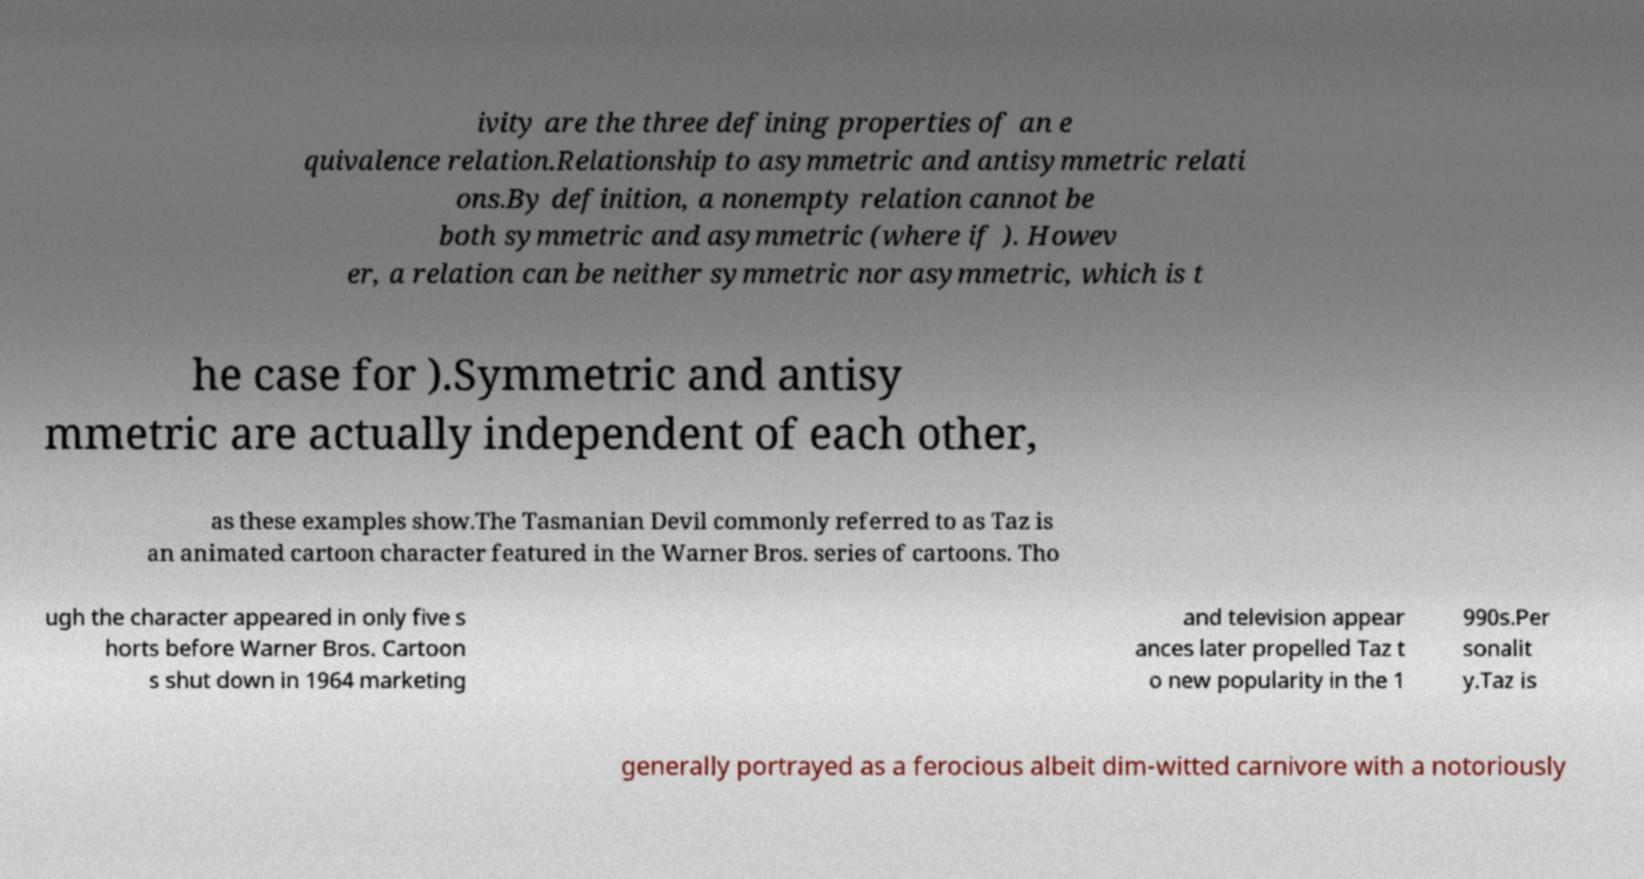Please identify and transcribe the text found in this image. ivity are the three defining properties of an e quivalence relation.Relationship to asymmetric and antisymmetric relati ons.By definition, a nonempty relation cannot be both symmetric and asymmetric (where if ). Howev er, a relation can be neither symmetric nor asymmetric, which is t he case for ).Symmetric and antisy mmetric are actually independent of each other, as these examples show.The Tasmanian Devil commonly referred to as Taz is an animated cartoon character featured in the Warner Bros. series of cartoons. Tho ugh the character appeared in only five s horts before Warner Bros. Cartoon s shut down in 1964 marketing and television appear ances later propelled Taz t o new popularity in the 1 990s.Per sonalit y.Taz is generally portrayed as a ferocious albeit dim-witted carnivore with a notoriously 